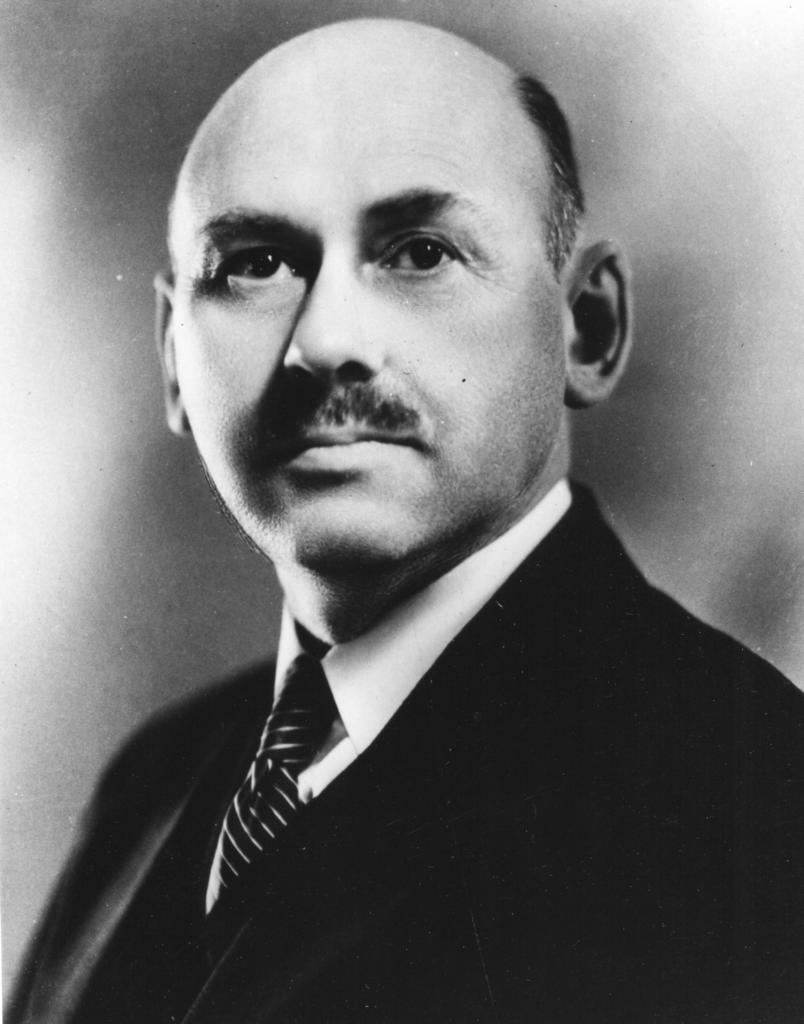What is the main subject of the image? There is a man in the image. What is the man wearing on his upper body? The man is wearing a black suit and a white shirt. What is the man wearing around his neck? The man is wearing a black tie. What type of faucet can be seen in the image? There is no faucet present in the image; it features a man wearing a black suit, white shirt, and black tie. What role does the minister play in the image? There is no minister present in the image, only a man wearing a suit, shirt, and tie. 